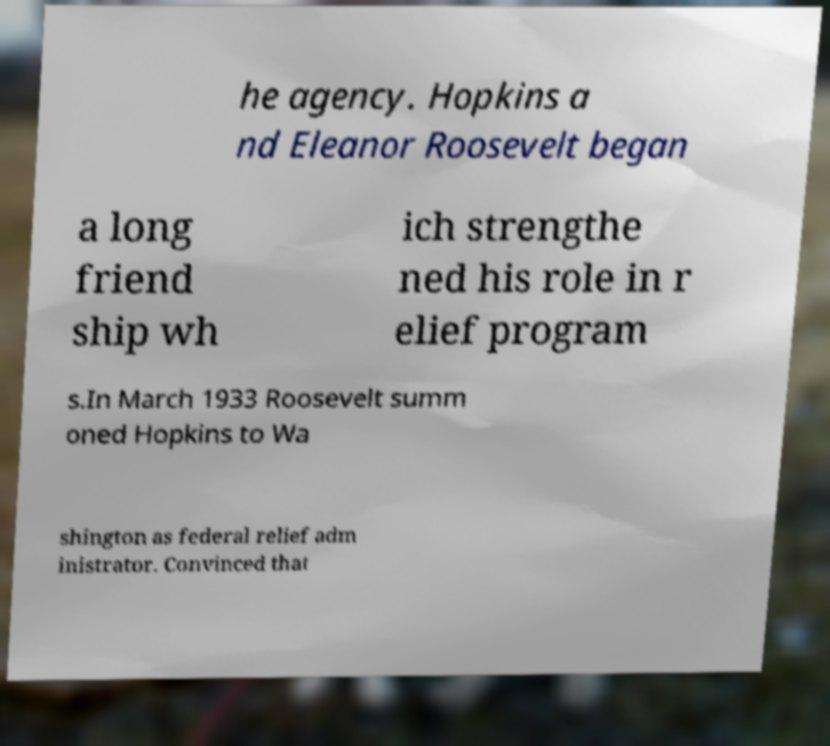Can you accurately transcribe the text from the provided image for me? he agency. Hopkins a nd Eleanor Roosevelt began a long friend ship wh ich strengthe ned his role in r elief program s.In March 1933 Roosevelt summ oned Hopkins to Wa shington as federal relief adm inistrator. Convinced that 